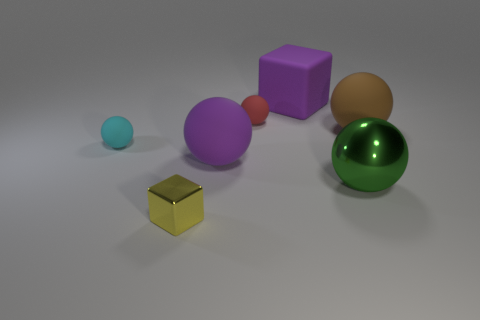Subtract all red balls. How many balls are left? 4 Subtract all large brown spheres. How many spheres are left? 4 Subtract all blue balls. Subtract all gray blocks. How many balls are left? 5 Add 1 small red rubber objects. How many objects exist? 8 Subtract all spheres. How many objects are left? 2 Add 1 big green balls. How many big green balls are left? 2 Add 4 large cubes. How many large cubes exist? 5 Subtract 0 cyan cylinders. How many objects are left? 7 Subtract all big green metallic things. Subtract all things. How many objects are left? 5 